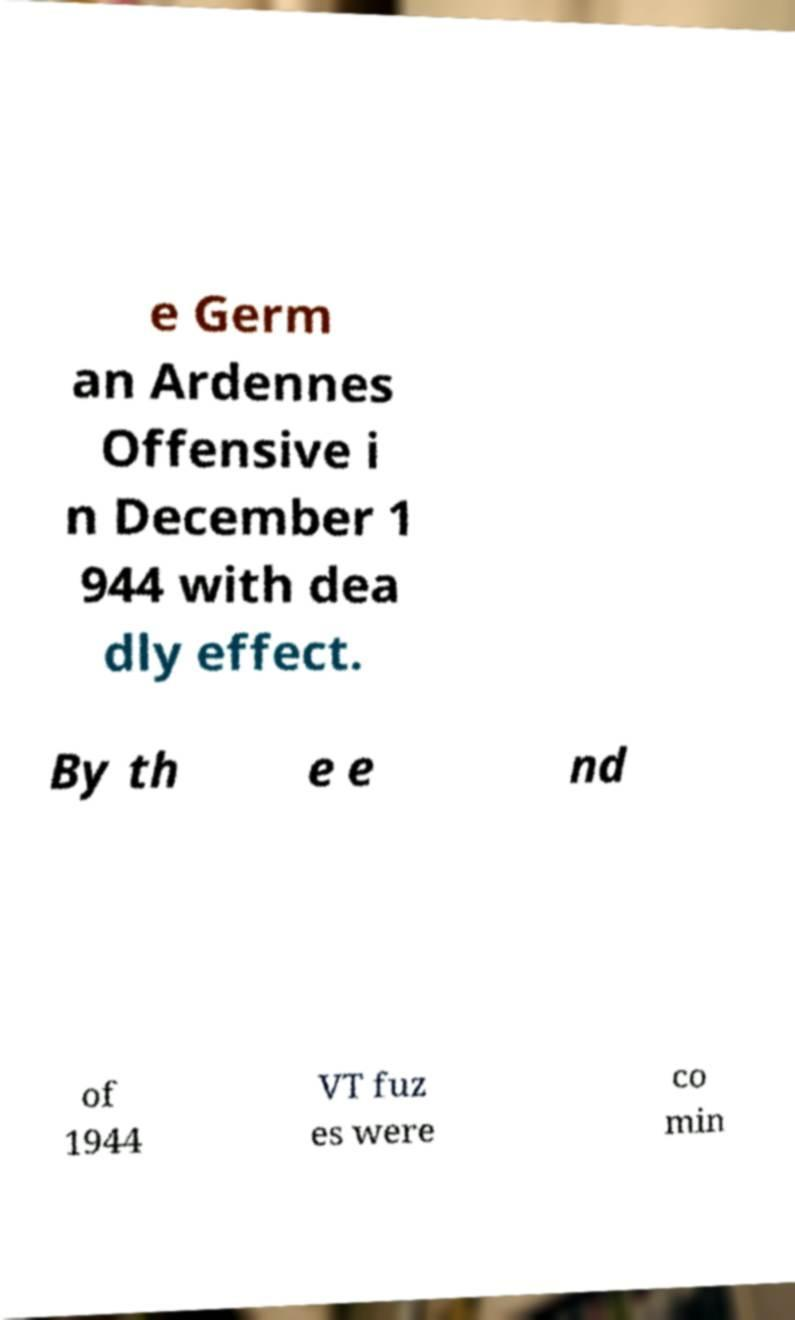Please read and relay the text visible in this image. What does it say? e Germ an Ardennes Offensive i n December 1 944 with dea dly effect. By th e e nd of 1944 VT fuz es were co min 